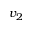Convert formula to latex. <formula><loc_0><loc_0><loc_500><loc_500>v _ { 2 }</formula> 